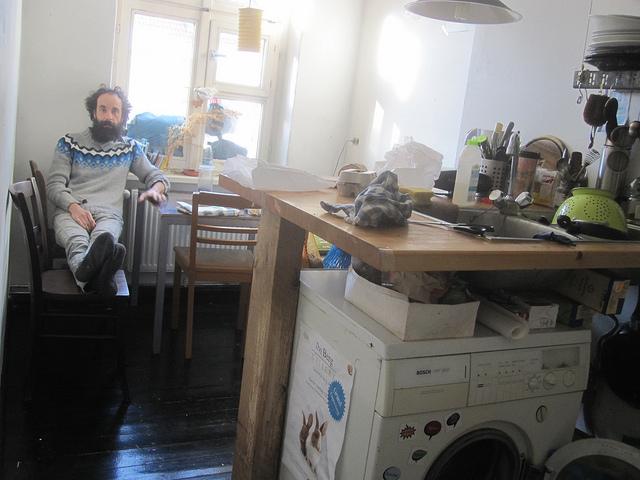Does that gentlemen need a shave?
Give a very brief answer. Yes. How many chairs is this man sitting on?
Keep it brief. 2. What appliance is in the right corner?
Be succinct. Dryer. 